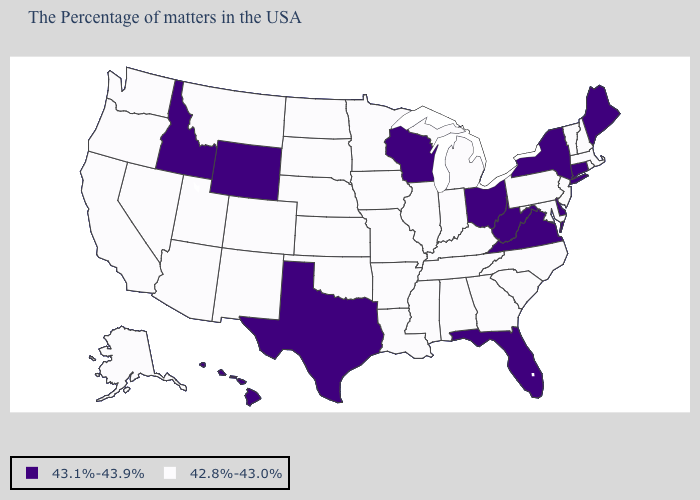What is the value of Washington?
Quick response, please. 42.8%-43.0%. What is the lowest value in the MidWest?
Concise answer only. 42.8%-43.0%. What is the value of Maryland?
Answer briefly. 42.8%-43.0%. Among the states that border Colorado , which have the lowest value?
Answer briefly. Kansas, Nebraska, Oklahoma, New Mexico, Utah, Arizona. Name the states that have a value in the range 42.8%-43.0%?
Write a very short answer. Massachusetts, Rhode Island, New Hampshire, Vermont, New Jersey, Maryland, Pennsylvania, North Carolina, South Carolina, Georgia, Michigan, Kentucky, Indiana, Alabama, Tennessee, Illinois, Mississippi, Louisiana, Missouri, Arkansas, Minnesota, Iowa, Kansas, Nebraska, Oklahoma, South Dakota, North Dakota, Colorado, New Mexico, Utah, Montana, Arizona, Nevada, California, Washington, Oregon, Alaska. Among the states that border Alabama , does Florida have the lowest value?
Concise answer only. No. What is the value of Minnesota?
Answer briefly. 42.8%-43.0%. What is the value of Alaska?
Keep it brief. 42.8%-43.0%. Does Montana have the lowest value in the USA?
Write a very short answer. Yes. What is the lowest value in the Northeast?
Concise answer only. 42.8%-43.0%. Name the states that have a value in the range 42.8%-43.0%?
Be succinct. Massachusetts, Rhode Island, New Hampshire, Vermont, New Jersey, Maryland, Pennsylvania, North Carolina, South Carolina, Georgia, Michigan, Kentucky, Indiana, Alabama, Tennessee, Illinois, Mississippi, Louisiana, Missouri, Arkansas, Minnesota, Iowa, Kansas, Nebraska, Oklahoma, South Dakota, North Dakota, Colorado, New Mexico, Utah, Montana, Arizona, Nevada, California, Washington, Oregon, Alaska. Among the states that border Wisconsin , which have the lowest value?
Give a very brief answer. Michigan, Illinois, Minnesota, Iowa. What is the lowest value in the West?
Concise answer only. 42.8%-43.0%. What is the highest value in the South ?
Quick response, please. 43.1%-43.9%. What is the value of Vermont?
Concise answer only. 42.8%-43.0%. 